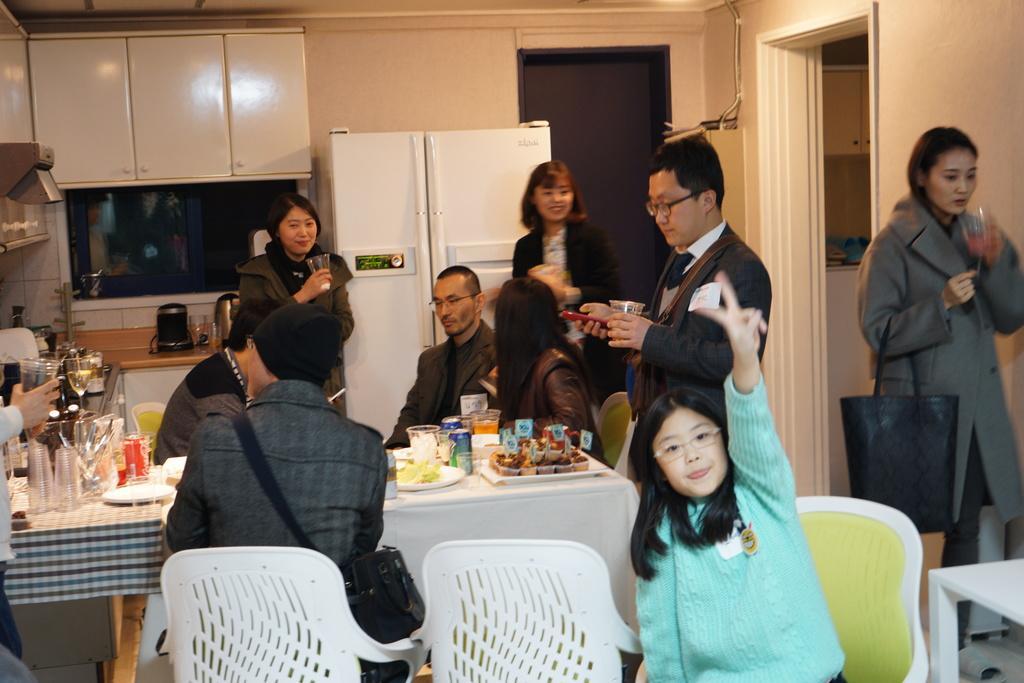How would you summarize this image in a sentence or two? The image is taken inside the kitchen. In the center of the image there is a table and there are people sitting around the table. There are chairs. On the right there is a lady standing and holding a glass in her hand. On the table we can see plates, food, tins, glasses spoons. In the background there is a refrigerator, cup board, a wall and a door. 